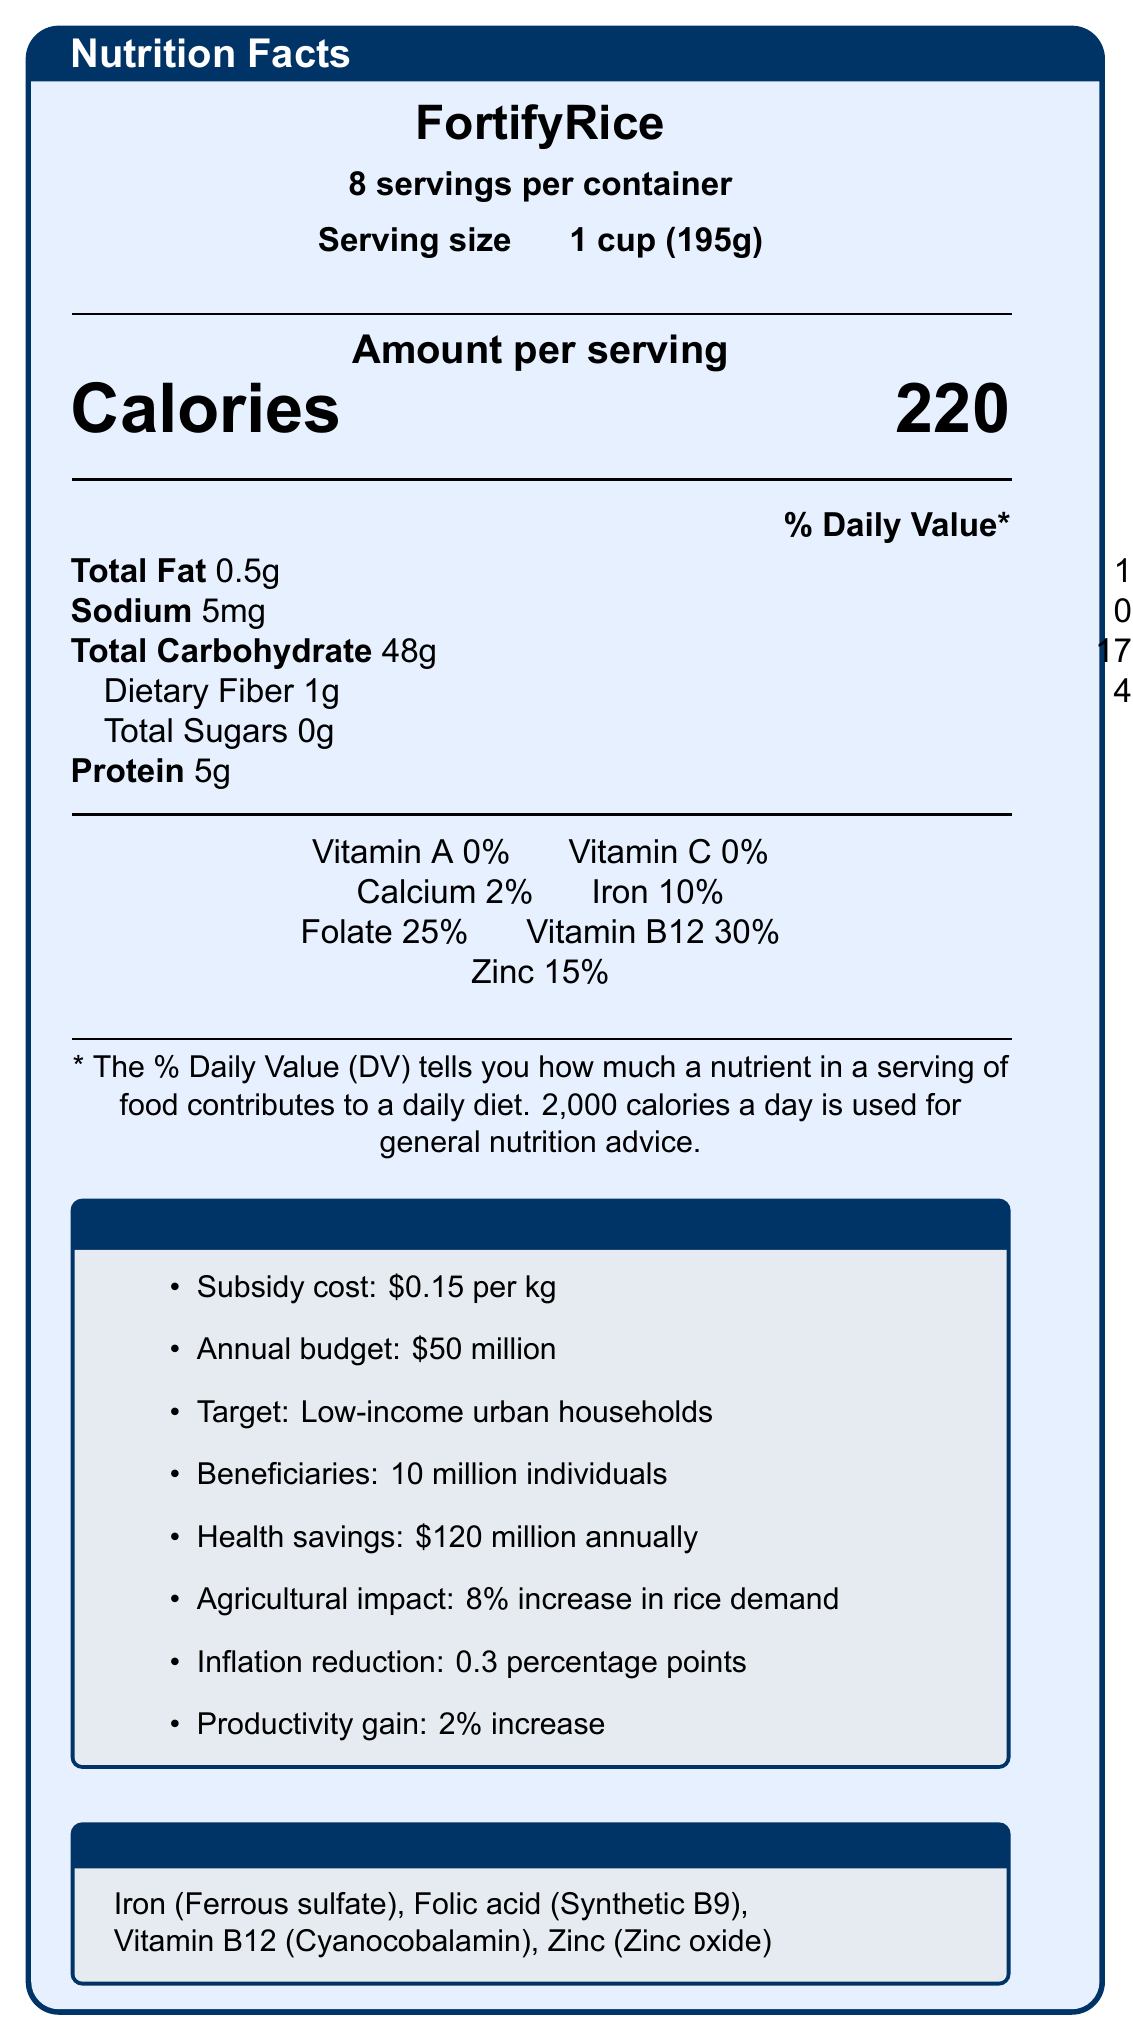What is the serving size of FortifyRice? The document states that the serving size is 1 cup, which is equivalent to 195 grams.
Answer: 1 cup (195g) How many calories are in one serving of FortifyRice? It is explicitly mentioned in the document under the section "Amount per serving."
Answer: 220 What is the percentage of the daily value of iron provided by one serving of FortifyRice? The document lists the iron content under the nutrients section, stating it as 10% of the daily value.
Answer: 10% Who is the target population for FortifyRice? This information is specified within the Economic Impact section.
Answer: Low-income households in urban areas How much is the subsidy cost for FortifyRice per kilogram? The subsidy cost is clearly outlined in the Economic Impact box in the document.
Answer: $0.15 per kg How much does the annual budget allocation for FortifyRice program amount to? A. $10 million B. $50 million C. $100 million As mentioned in the Economic Impact section, the annual budget allocation is $50 million.
Answer: B. $50 million Which of the following nutrients are included in FortifyRice’s fortification? I. Vitamin A II. Iron III. Folate IV. Vitamin B12 The Fortification box lists Iron (Ferrous sulfate), Folic acid (Synthetic B9), and Vitamin B12 (Cyanocobalamin), not Vitamin A.
Answer: II, III, IV Does FortifyRice contribute to reducing food inflation? The Economic Impact section states that FortifyRice has the potential to reduce food inflation by 0.3 percentage points.
Answer: Yes What is the expected annual health savings associated with FortifyRice? According to the Economic Impact section, the expected health savings are $120 million annually.
Answer: $120 million Describe the main idea of the document. The document details FortifyRice's nutritional facts, economic impact, fortification specifics, sustainability metrics, market analysis, and policy implications. It aims to provide a comprehensive overview of the benefits and effects of this government-subsidized food product.
Answer: FortifyRice is a government-subsidized fortified rice product aimed at low-income urban households. The product offers a variety of nutritional benefits, including iron, folate, vitamin B12, and zinc. The economic impact includes significant health savings, increased demand for domestic rice, and inflation mitigation. The document also outlines the sustainability metrics and market analysis for FortifyRice. What is the environmental impact of FortifyRice in terms of water usage? The Sustainability Metrics section states that FortifyRice uses 30% less water than conventional rice production.
Answer: 30% less than conventional rice production How does FortifyRice compare to non-subsidized fortified rice brands in terms of price? The Market Analysis section notes that FortifyRice is 20% cheaper than non-subsidized fortified rice brands.
Answer: 20% lower What is the potential reduction in rice imports due to FortifyRice? The Policy Implications section indicates a potential reduction in rice imports by 5%.
Answer: 5% What are the ingredients used for vitamin fortification in FortifyRice? This information is provided in the Fortification box in the document.
Answer: Iron (Ferrous sulfate), Folic acid (Synthetic B9), Vitamin B12 (Cyanocobalamin), Zinc (Zinc oxide) Is FortifyRice's packaging recyclable? The Sustainability Metrics section states that the packaging is 100% recyclable.
Answer: Yes What is the percentage of the fortified rice market that FortifyRice holds in target regions? This data is listed in the Market Analysis section, stating a market share of 35%.
Answer: 35% How many servings are in one container of FortifyRice? The document explicitly states there are 8 servings per container.
Answer: 8 What is the percentage of daily value for dietary fiber in one serving of FortifyRice? The document lists dietary fiber as providing 4% of the daily value per serving.
Answer: 4% What is the primary goal of the FortifyRice program in terms of food security policy? This is detailed in the Policy Implications section of the document.
Answer: Contributes to achieving Sustainable Development Goal 2: Zero Hunger. What kind of feedback did FortifyRice receive in pilot studies? The Market Analysis section states that 78% positive feedback was received in pilot studies.
Answer: 78% positive What is the increase in labor productivity estimated due to improved nutrition from FortifyRice? The document mentions an estimated 2% increase in labor productivity in the Economic Impact section.
Answer: 2% What is the amount of total sugars in one serving of FortifyRice? The nutritional facts list that there are zero grams of total sugars in one serving.
Answer: 0g What are the sources of Vitamin A and Vitamin C in FortifyRice? The document states that Vitamin A and Vitamin C are 0%, and no sources are specified.
Answer: Cannot be determined What is the daily value of Vitamin B12 in one serving of FortifyRice? According to the nutritional information, Vitamin B12 contributes 30% of the daily value per serving.
Answer: 30% 